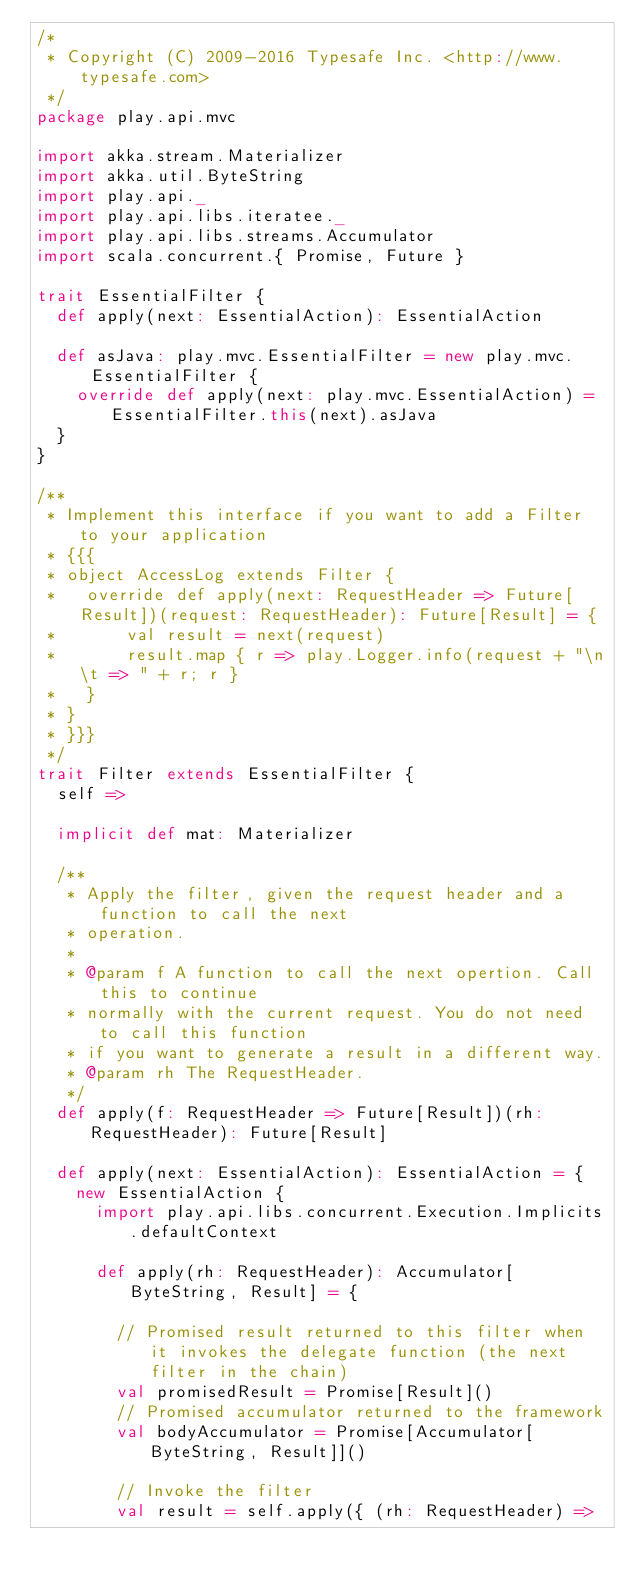Convert code to text. <code><loc_0><loc_0><loc_500><loc_500><_Scala_>/*
 * Copyright (C) 2009-2016 Typesafe Inc. <http://www.typesafe.com>
 */
package play.api.mvc

import akka.stream.Materializer
import akka.util.ByteString
import play.api._
import play.api.libs.iteratee._
import play.api.libs.streams.Accumulator
import scala.concurrent.{ Promise, Future }

trait EssentialFilter {
  def apply(next: EssentialAction): EssentialAction

  def asJava: play.mvc.EssentialFilter = new play.mvc.EssentialFilter {
    override def apply(next: play.mvc.EssentialAction) = EssentialFilter.this(next).asJava
  }
}

/**
 * Implement this interface if you want to add a Filter to your application
 * {{{
 * object AccessLog extends Filter {
 *   override def apply(next: RequestHeader => Future[Result])(request: RequestHeader): Future[Result] = {
 * 		 val result = next(request)
 * 		 result.map { r => play.Logger.info(request + "\n\t => " + r; r }
 * 	 }
 * }
 * }}}
 */
trait Filter extends EssentialFilter {
  self =>

  implicit def mat: Materializer

  /**
   * Apply the filter, given the request header and a function to call the next
   * operation.
   *
   * @param f A function to call the next opertion. Call this to continue
   * normally with the current request. You do not need to call this function
   * if you want to generate a result in a different way.
   * @param rh The RequestHeader.
   */
  def apply(f: RequestHeader => Future[Result])(rh: RequestHeader): Future[Result]

  def apply(next: EssentialAction): EssentialAction = {
    new EssentialAction {
      import play.api.libs.concurrent.Execution.Implicits.defaultContext

      def apply(rh: RequestHeader): Accumulator[ByteString, Result] = {

        // Promised result returned to this filter when it invokes the delegate function (the next filter in the chain)
        val promisedResult = Promise[Result]()
        // Promised accumulator returned to the framework
        val bodyAccumulator = Promise[Accumulator[ByteString, Result]]()

        // Invoke the filter
        val result = self.apply({ (rh: RequestHeader) =></code> 